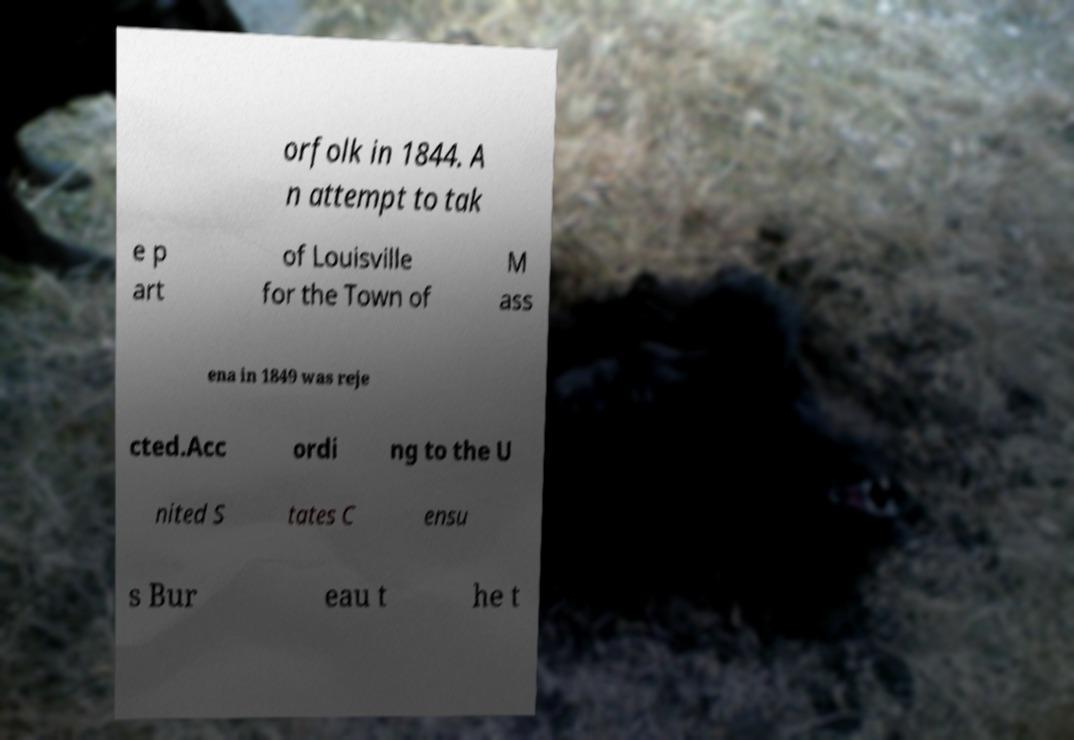Can you accurately transcribe the text from the provided image for me? orfolk in 1844. A n attempt to tak e p art of Louisville for the Town of M ass ena in 1849 was reje cted.Acc ordi ng to the U nited S tates C ensu s Bur eau t he t 